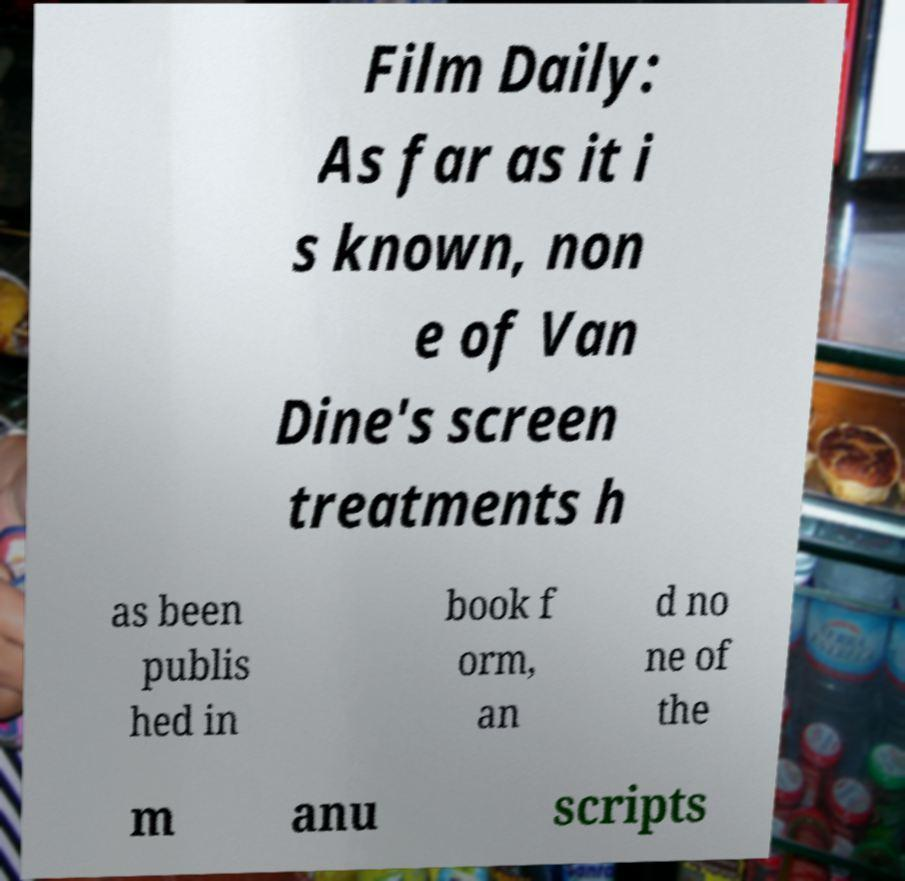There's text embedded in this image that I need extracted. Can you transcribe it verbatim? Film Daily: As far as it i s known, non e of Van Dine's screen treatments h as been publis hed in book f orm, an d no ne of the m anu scripts 